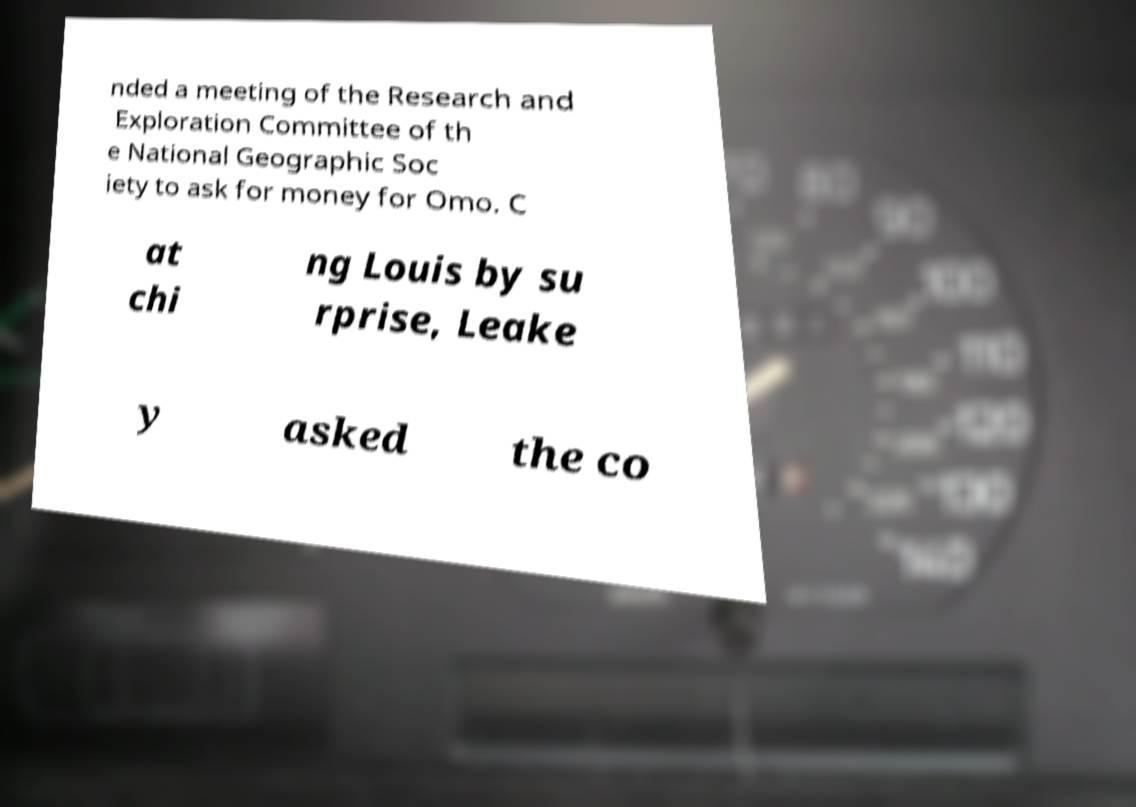Can you accurately transcribe the text from the provided image for me? nded a meeting of the Research and Exploration Committee of th e National Geographic Soc iety to ask for money for Omo. C at chi ng Louis by su rprise, Leake y asked the co 